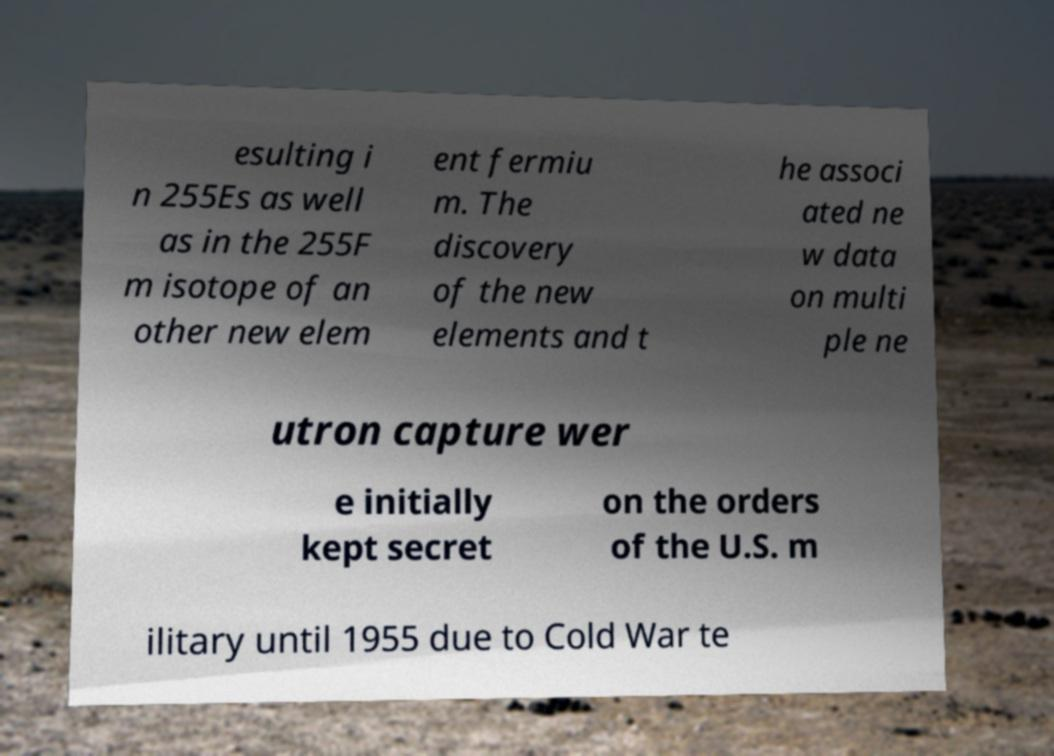For documentation purposes, I need the text within this image transcribed. Could you provide that? esulting i n 255Es as well as in the 255F m isotope of an other new elem ent fermiu m. The discovery of the new elements and t he associ ated ne w data on multi ple ne utron capture wer e initially kept secret on the orders of the U.S. m ilitary until 1955 due to Cold War te 